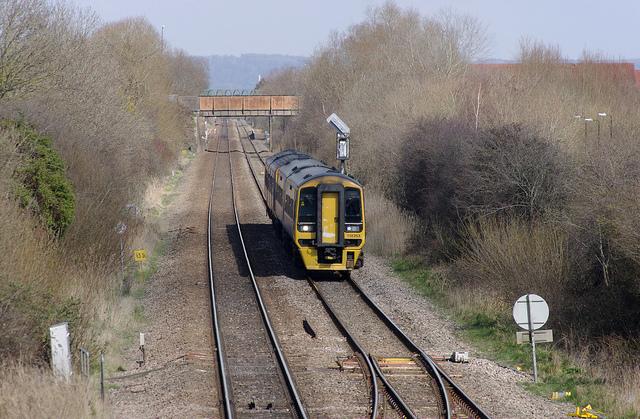How many tracks can you spot?
Short answer required. 2. Are there leaves on most of the trees?
Quick response, please. No. Is this train traveling under a cloud?
Concise answer only. No. Does the train look happy?
Concise answer only. Yes. Is this an electric train?
Short answer required. Yes. Is this modern?
Write a very short answer. Yes. Is this a train station?
Concise answer only. No. What color is the train?
Short answer required. Yellow. Is this a steam engine?
Concise answer only. No. 